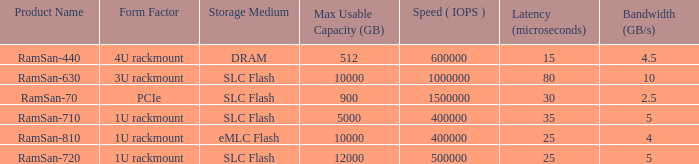I'm looking to parse the entire table for insights. Could you assist me with that? {'header': ['Product Name', 'Form Factor', 'Storage Medium', 'Max Usable Capacity (GB)', 'Speed ( IOPS )', 'Latency (microseconds)', 'Bandwidth (GB/s)'], 'rows': [['RamSan-440', '4U rackmount', 'DRAM', '512', '600000', '15', '4.5'], ['RamSan-630', '3U rackmount', 'SLC Flash', '10000', '1000000', '80', '10'], ['RamSan-70', 'PCIe', 'SLC Flash', '900', '1500000', '30', '2.5'], ['RamSan-710', '1U rackmount', 'SLC Flash', '5000', '400000', '35', '5'], ['RamSan-810', '1U rackmount', 'eMLC Flash', '10000', '400000', '25', '4'], ['RamSan-720', '1U rackmount', 'SLC Flash', '12000', '500000', '25', '5']]} What is the ramsan-810 transfer delay? 1.0. 